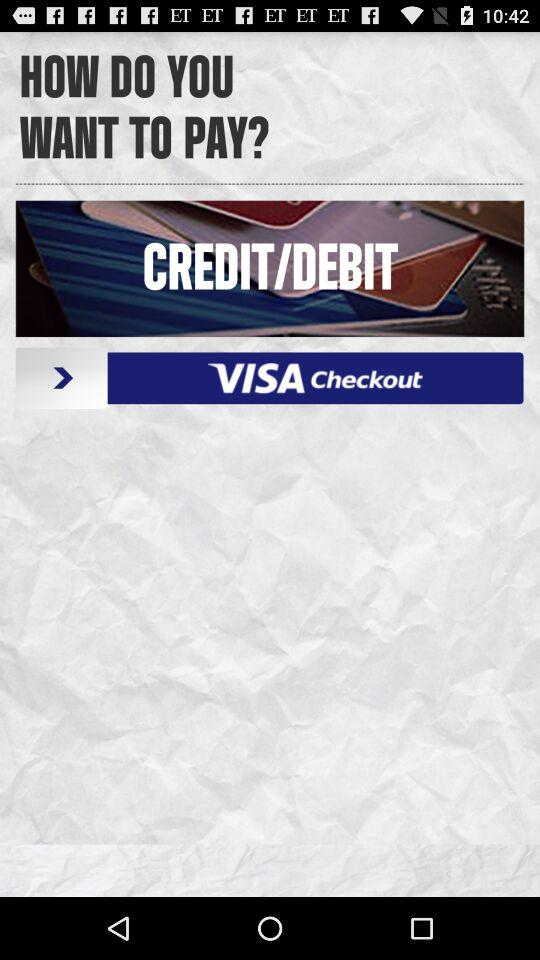What are the different options available for payment? The different options available for payment are credit card and debit card. 